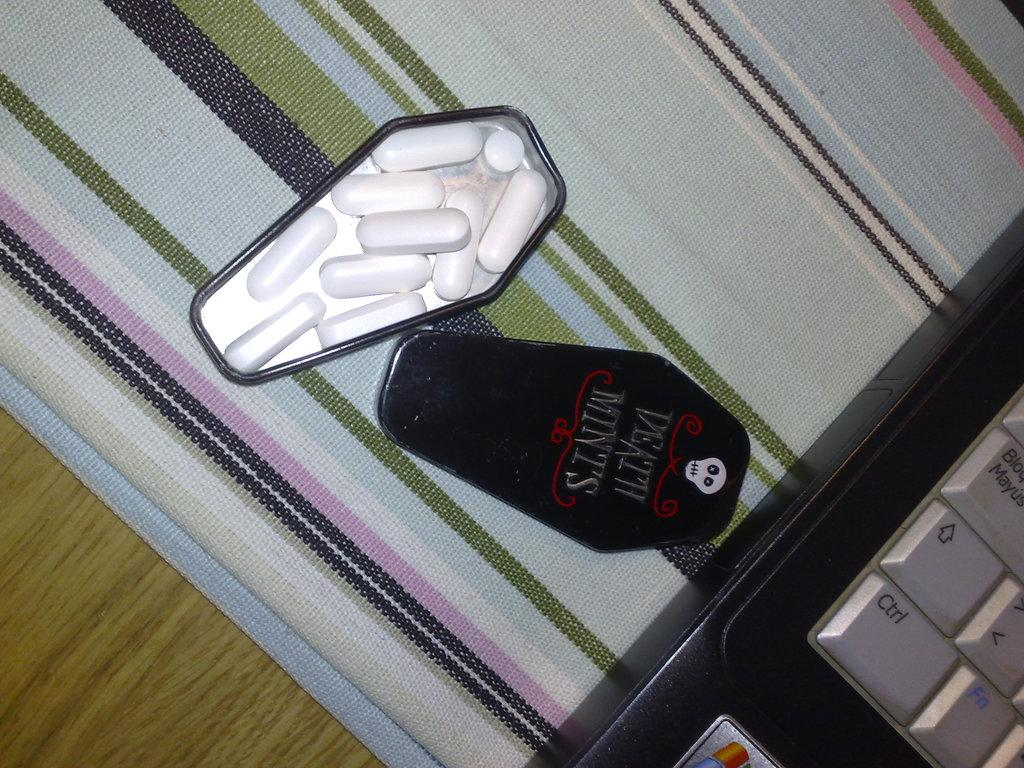<image>
Offer a succinct explanation of the picture presented. Box of medicine inside a coffin saying Death Mints. 